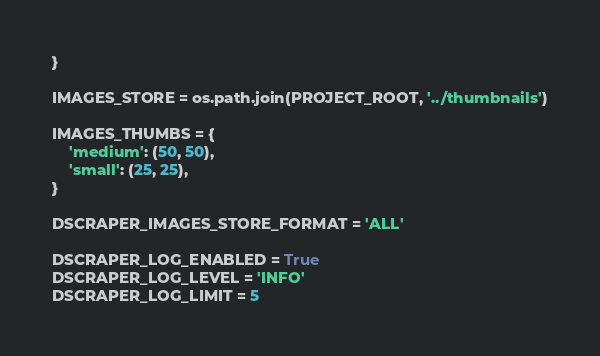<code> <loc_0><loc_0><loc_500><loc_500><_Python_>}

IMAGES_STORE = os.path.join(PROJECT_ROOT, '../thumbnails')

IMAGES_THUMBS = {
    'medium': (50, 50),
    'small': (25, 25),
}

DSCRAPER_IMAGES_STORE_FORMAT = 'ALL'

DSCRAPER_LOG_ENABLED = True
DSCRAPER_LOG_LEVEL = 'INFO'
DSCRAPER_LOG_LIMIT = 5</code> 